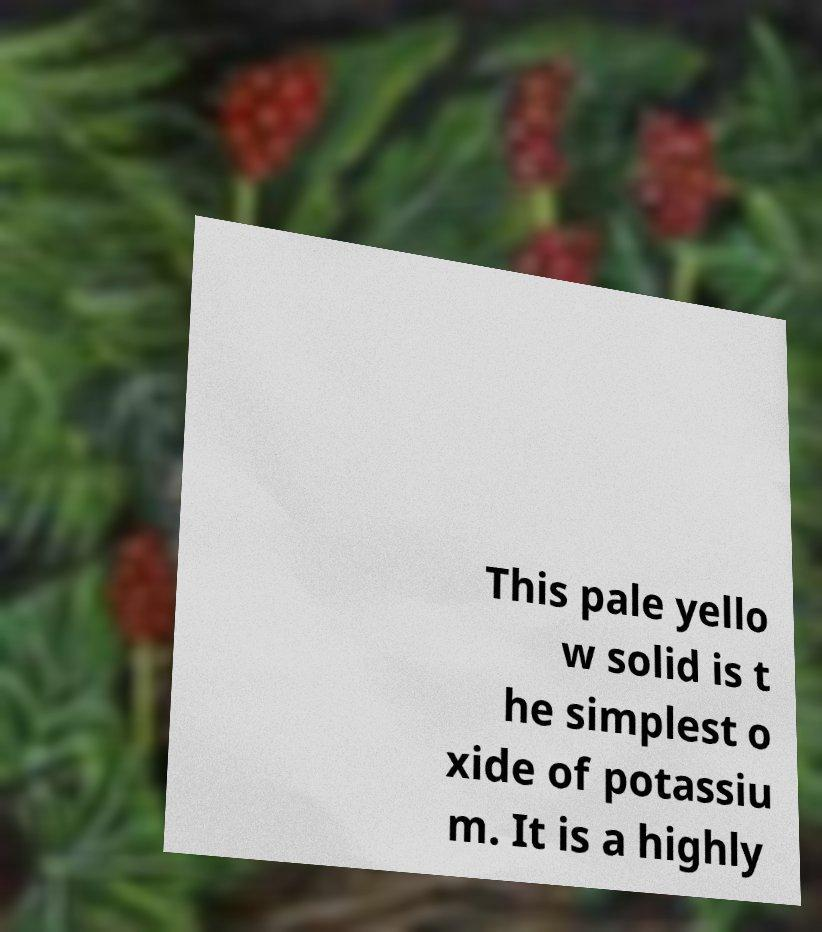Could you extract and type out the text from this image? This pale yello w solid is t he simplest o xide of potassiu m. It is a highly 